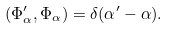<formula> <loc_0><loc_0><loc_500><loc_500>( \Phi _ { \alpha } ^ { \prime } , \Phi _ { \alpha } ) = \delta ( \alpha ^ { \prime } - \alpha ) .</formula> 